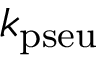<formula> <loc_0><loc_0><loc_500><loc_500>k _ { p s e u }</formula> 